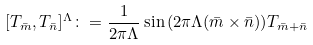Convert formula to latex. <formula><loc_0><loc_0><loc_500><loc_500>[ T _ { \bar { m } } , T _ { \bar { n } } ] ^ { \Lambda } \colon = \frac { 1 } { 2 \pi \Lambda } \sin { \left ( 2 \pi \Lambda ( \bar { m } \times \bar { n } ) \right ) } T _ { \bar { m } + \bar { n } }</formula> 